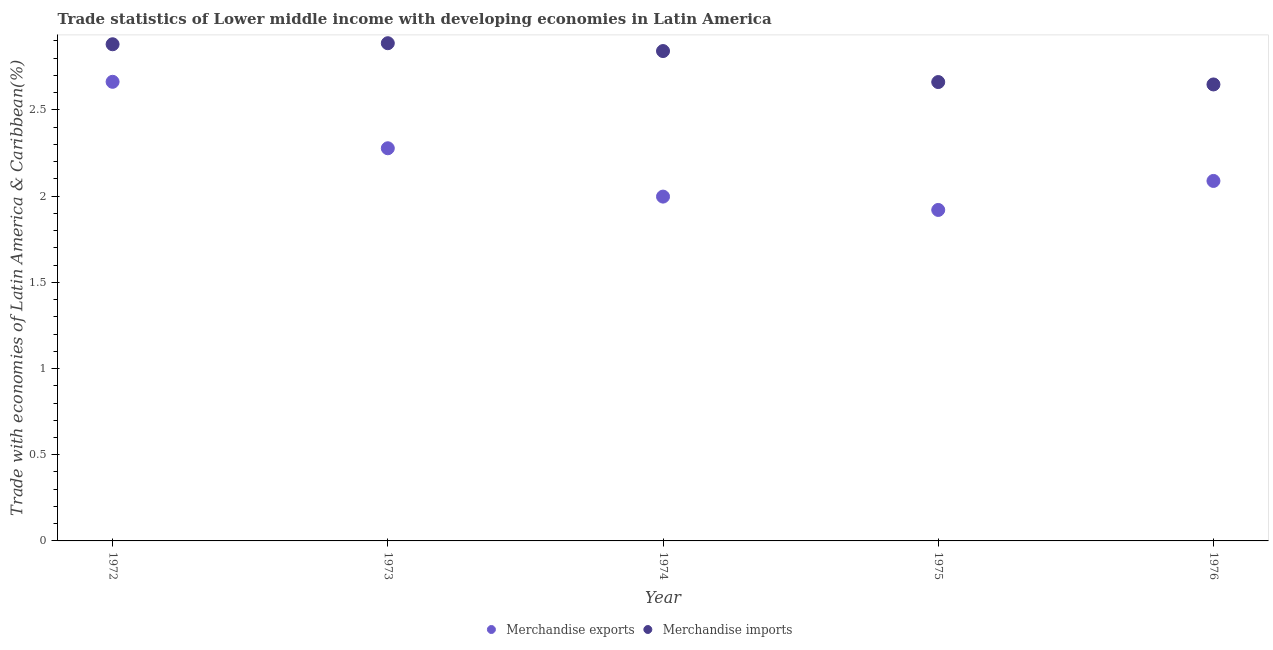How many different coloured dotlines are there?
Keep it short and to the point. 2. What is the merchandise exports in 1976?
Your answer should be very brief. 2.09. Across all years, what is the maximum merchandise imports?
Make the answer very short. 2.89. Across all years, what is the minimum merchandise imports?
Make the answer very short. 2.65. In which year was the merchandise exports maximum?
Ensure brevity in your answer.  1972. In which year was the merchandise exports minimum?
Your response must be concise. 1975. What is the total merchandise imports in the graph?
Your answer should be very brief. 13.92. What is the difference between the merchandise imports in 1972 and that in 1976?
Provide a short and direct response. 0.23. What is the difference between the merchandise imports in 1975 and the merchandise exports in 1973?
Ensure brevity in your answer.  0.38. What is the average merchandise exports per year?
Your answer should be compact. 2.19. In the year 1974, what is the difference between the merchandise exports and merchandise imports?
Offer a terse response. -0.84. In how many years, is the merchandise exports greater than 0.8 %?
Your response must be concise. 5. What is the ratio of the merchandise exports in 1974 to that in 1975?
Your answer should be compact. 1.04. Is the merchandise exports in 1974 less than that in 1976?
Make the answer very short. Yes. What is the difference between the highest and the second highest merchandise exports?
Keep it short and to the point. 0.39. What is the difference between the highest and the lowest merchandise imports?
Give a very brief answer. 0.24. In how many years, is the merchandise imports greater than the average merchandise imports taken over all years?
Offer a terse response. 3. Is the sum of the merchandise imports in 1973 and 1976 greater than the maximum merchandise exports across all years?
Give a very brief answer. Yes. Is the merchandise exports strictly greater than the merchandise imports over the years?
Your answer should be very brief. No. Is the merchandise imports strictly less than the merchandise exports over the years?
Provide a succinct answer. No. How many years are there in the graph?
Give a very brief answer. 5. Where does the legend appear in the graph?
Ensure brevity in your answer.  Bottom center. How many legend labels are there?
Offer a terse response. 2. How are the legend labels stacked?
Offer a very short reply. Horizontal. What is the title of the graph?
Make the answer very short. Trade statistics of Lower middle income with developing economies in Latin America. What is the label or title of the X-axis?
Provide a short and direct response. Year. What is the label or title of the Y-axis?
Your answer should be very brief. Trade with economies of Latin America & Caribbean(%). What is the Trade with economies of Latin America & Caribbean(%) of Merchandise exports in 1972?
Make the answer very short. 2.66. What is the Trade with economies of Latin America & Caribbean(%) of Merchandise imports in 1972?
Give a very brief answer. 2.88. What is the Trade with economies of Latin America & Caribbean(%) of Merchandise exports in 1973?
Your answer should be compact. 2.28. What is the Trade with economies of Latin America & Caribbean(%) in Merchandise imports in 1973?
Give a very brief answer. 2.89. What is the Trade with economies of Latin America & Caribbean(%) in Merchandise exports in 1974?
Provide a succinct answer. 2. What is the Trade with economies of Latin America & Caribbean(%) of Merchandise imports in 1974?
Offer a terse response. 2.84. What is the Trade with economies of Latin America & Caribbean(%) of Merchandise exports in 1975?
Keep it short and to the point. 1.92. What is the Trade with economies of Latin America & Caribbean(%) of Merchandise imports in 1975?
Your answer should be very brief. 2.66. What is the Trade with economies of Latin America & Caribbean(%) in Merchandise exports in 1976?
Your response must be concise. 2.09. What is the Trade with economies of Latin America & Caribbean(%) in Merchandise imports in 1976?
Your answer should be compact. 2.65. Across all years, what is the maximum Trade with economies of Latin America & Caribbean(%) of Merchandise exports?
Your response must be concise. 2.66. Across all years, what is the maximum Trade with economies of Latin America & Caribbean(%) of Merchandise imports?
Give a very brief answer. 2.89. Across all years, what is the minimum Trade with economies of Latin America & Caribbean(%) in Merchandise exports?
Provide a short and direct response. 1.92. Across all years, what is the minimum Trade with economies of Latin America & Caribbean(%) in Merchandise imports?
Give a very brief answer. 2.65. What is the total Trade with economies of Latin America & Caribbean(%) of Merchandise exports in the graph?
Give a very brief answer. 10.95. What is the total Trade with economies of Latin America & Caribbean(%) in Merchandise imports in the graph?
Offer a terse response. 13.92. What is the difference between the Trade with economies of Latin America & Caribbean(%) in Merchandise exports in 1972 and that in 1973?
Your response must be concise. 0.39. What is the difference between the Trade with economies of Latin America & Caribbean(%) in Merchandise imports in 1972 and that in 1973?
Your answer should be compact. -0.01. What is the difference between the Trade with economies of Latin America & Caribbean(%) in Merchandise exports in 1972 and that in 1974?
Provide a succinct answer. 0.67. What is the difference between the Trade with economies of Latin America & Caribbean(%) in Merchandise imports in 1972 and that in 1974?
Your answer should be compact. 0.04. What is the difference between the Trade with economies of Latin America & Caribbean(%) in Merchandise exports in 1972 and that in 1975?
Your response must be concise. 0.74. What is the difference between the Trade with economies of Latin America & Caribbean(%) of Merchandise imports in 1972 and that in 1975?
Your answer should be very brief. 0.22. What is the difference between the Trade with economies of Latin America & Caribbean(%) of Merchandise exports in 1972 and that in 1976?
Your answer should be compact. 0.57. What is the difference between the Trade with economies of Latin America & Caribbean(%) of Merchandise imports in 1972 and that in 1976?
Provide a succinct answer. 0.23. What is the difference between the Trade with economies of Latin America & Caribbean(%) of Merchandise exports in 1973 and that in 1974?
Your answer should be compact. 0.28. What is the difference between the Trade with economies of Latin America & Caribbean(%) in Merchandise imports in 1973 and that in 1974?
Give a very brief answer. 0.05. What is the difference between the Trade with economies of Latin America & Caribbean(%) in Merchandise exports in 1973 and that in 1975?
Your response must be concise. 0.36. What is the difference between the Trade with economies of Latin America & Caribbean(%) in Merchandise imports in 1973 and that in 1975?
Ensure brevity in your answer.  0.23. What is the difference between the Trade with economies of Latin America & Caribbean(%) in Merchandise exports in 1973 and that in 1976?
Ensure brevity in your answer.  0.19. What is the difference between the Trade with economies of Latin America & Caribbean(%) in Merchandise imports in 1973 and that in 1976?
Your answer should be very brief. 0.24. What is the difference between the Trade with economies of Latin America & Caribbean(%) of Merchandise exports in 1974 and that in 1975?
Offer a very short reply. 0.08. What is the difference between the Trade with economies of Latin America & Caribbean(%) in Merchandise imports in 1974 and that in 1975?
Provide a succinct answer. 0.18. What is the difference between the Trade with economies of Latin America & Caribbean(%) in Merchandise exports in 1974 and that in 1976?
Your answer should be compact. -0.09. What is the difference between the Trade with economies of Latin America & Caribbean(%) of Merchandise imports in 1974 and that in 1976?
Provide a short and direct response. 0.19. What is the difference between the Trade with economies of Latin America & Caribbean(%) of Merchandise exports in 1975 and that in 1976?
Your answer should be very brief. -0.17. What is the difference between the Trade with economies of Latin America & Caribbean(%) of Merchandise imports in 1975 and that in 1976?
Offer a very short reply. 0.01. What is the difference between the Trade with economies of Latin America & Caribbean(%) in Merchandise exports in 1972 and the Trade with economies of Latin America & Caribbean(%) in Merchandise imports in 1973?
Keep it short and to the point. -0.22. What is the difference between the Trade with economies of Latin America & Caribbean(%) of Merchandise exports in 1972 and the Trade with economies of Latin America & Caribbean(%) of Merchandise imports in 1974?
Your response must be concise. -0.18. What is the difference between the Trade with economies of Latin America & Caribbean(%) of Merchandise exports in 1972 and the Trade with economies of Latin America & Caribbean(%) of Merchandise imports in 1975?
Provide a short and direct response. 0. What is the difference between the Trade with economies of Latin America & Caribbean(%) of Merchandise exports in 1972 and the Trade with economies of Latin America & Caribbean(%) of Merchandise imports in 1976?
Offer a very short reply. 0.02. What is the difference between the Trade with economies of Latin America & Caribbean(%) in Merchandise exports in 1973 and the Trade with economies of Latin America & Caribbean(%) in Merchandise imports in 1974?
Your answer should be compact. -0.56. What is the difference between the Trade with economies of Latin America & Caribbean(%) of Merchandise exports in 1973 and the Trade with economies of Latin America & Caribbean(%) of Merchandise imports in 1975?
Offer a terse response. -0.38. What is the difference between the Trade with economies of Latin America & Caribbean(%) of Merchandise exports in 1973 and the Trade with economies of Latin America & Caribbean(%) of Merchandise imports in 1976?
Your response must be concise. -0.37. What is the difference between the Trade with economies of Latin America & Caribbean(%) in Merchandise exports in 1974 and the Trade with economies of Latin America & Caribbean(%) in Merchandise imports in 1975?
Your response must be concise. -0.66. What is the difference between the Trade with economies of Latin America & Caribbean(%) in Merchandise exports in 1974 and the Trade with economies of Latin America & Caribbean(%) in Merchandise imports in 1976?
Keep it short and to the point. -0.65. What is the difference between the Trade with economies of Latin America & Caribbean(%) of Merchandise exports in 1975 and the Trade with economies of Latin America & Caribbean(%) of Merchandise imports in 1976?
Give a very brief answer. -0.73. What is the average Trade with economies of Latin America & Caribbean(%) of Merchandise exports per year?
Your answer should be very brief. 2.19. What is the average Trade with economies of Latin America & Caribbean(%) of Merchandise imports per year?
Offer a terse response. 2.78. In the year 1972, what is the difference between the Trade with economies of Latin America & Caribbean(%) in Merchandise exports and Trade with economies of Latin America & Caribbean(%) in Merchandise imports?
Keep it short and to the point. -0.22. In the year 1973, what is the difference between the Trade with economies of Latin America & Caribbean(%) of Merchandise exports and Trade with economies of Latin America & Caribbean(%) of Merchandise imports?
Ensure brevity in your answer.  -0.61. In the year 1974, what is the difference between the Trade with economies of Latin America & Caribbean(%) of Merchandise exports and Trade with economies of Latin America & Caribbean(%) of Merchandise imports?
Provide a succinct answer. -0.84. In the year 1975, what is the difference between the Trade with economies of Latin America & Caribbean(%) of Merchandise exports and Trade with economies of Latin America & Caribbean(%) of Merchandise imports?
Your answer should be compact. -0.74. In the year 1976, what is the difference between the Trade with economies of Latin America & Caribbean(%) of Merchandise exports and Trade with economies of Latin America & Caribbean(%) of Merchandise imports?
Your answer should be compact. -0.56. What is the ratio of the Trade with economies of Latin America & Caribbean(%) in Merchandise exports in 1972 to that in 1973?
Offer a terse response. 1.17. What is the ratio of the Trade with economies of Latin America & Caribbean(%) in Merchandise exports in 1972 to that in 1974?
Offer a very short reply. 1.33. What is the ratio of the Trade with economies of Latin America & Caribbean(%) of Merchandise imports in 1972 to that in 1974?
Offer a very short reply. 1.01. What is the ratio of the Trade with economies of Latin America & Caribbean(%) in Merchandise exports in 1972 to that in 1975?
Offer a terse response. 1.39. What is the ratio of the Trade with economies of Latin America & Caribbean(%) of Merchandise imports in 1972 to that in 1975?
Your answer should be very brief. 1.08. What is the ratio of the Trade with economies of Latin America & Caribbean(%) in Merchandise exports in 1972 to that in 1976?
Offer a terse response. 1.28. What is the ratio of the Trade with economies of Latin America & Caribbean(%) of Merchandise imports in 1972 to that in 1976?
Offer a terse response. 1.09. What is the ratio of the Trade with economies of Latin America & Caribbean(%) of Merchandise exports in 1973 to that in 1974?
Provide a succinct answer. 1.14. What is the ratio of the Trade with economies of Latin America & Caribbean(%) of Merchandise imports in 1973 to that in 1974?
Provide a short and direct response. 1.02. What is the ratio of the Trade with economies of Latin America & Caribbean(%) in Merchandise exports in 1973 to that in 1975?
Offer a terse response. 1.19. What is the ratio of the Trade with economies of Latin America & Caribbean(%) in Merchandise imports in 1973 to that in 1975?
Your response must be concise. 1.08. What is the ratio of the Trade with economies of Latin America & Caribbean(%) of Merchandise exports in 1973 to that in 1976?
Give a very brief answer. 1.09. What is the ratio of the Trade with economies of Latin America & Caribbean(%) of Merchandise imports in 1973 to that in 1976?
Keep it short and to the point. 1.09. What is the ratio of the Trade with economies of Latin America & Caribbean(%) in Merchandise exports in 1974 to that in 1975?
Provide a short and direct response. 1.04. What is the ratio of the Trade with economies of Latin America & Caribbean(%) of Merchandise imports in 1974 to that in 1975?
Provide a short and direct response. 1.07. What is the ratio of the Trade with economies of Latin America & Caribbean(%) of Merchandise exports in 1974 to that in 1976?
Your response must be concise. 0.96. What is the ratio of the Trade with economies of Latin America & Caribbean(%) of Merchandise imports in 1974 to that in 1976?
Make the answer very short. 1.07. What is the ratio of the Trade with economies of Latin America & Caribbean(%) of Merchandise exports in 1975 to that in 1976?
Your answer should be compact. 0.92. What is the ratio of the Trade with economies of Latin America & Caribbean(%) in Merchandise imports in 1975 to that in 1976?
Make the answer very short. 1.01. What is the difference between the highest and the second highest Trade with economies of Latin America & Caribbean(%) in Merchandise exports?
Your answer should be very brief. 0.39. What is the difference between the highest and the second highest Trade with economies of Latin America & Caribbean(%) of Merchandise imports?
Give a very brief answer. 0.01. What is the difference between the highest and the lowest Trade with economies of Latin America & Caribbean(%) of Merchandise exports?
Provide a short and direct response. 0.74. What is the difference between the highest and the lowest Trade with economies of Latin America & Caribbean(%) of Merchandise imports?
Your answer should be compact. 0.24. 